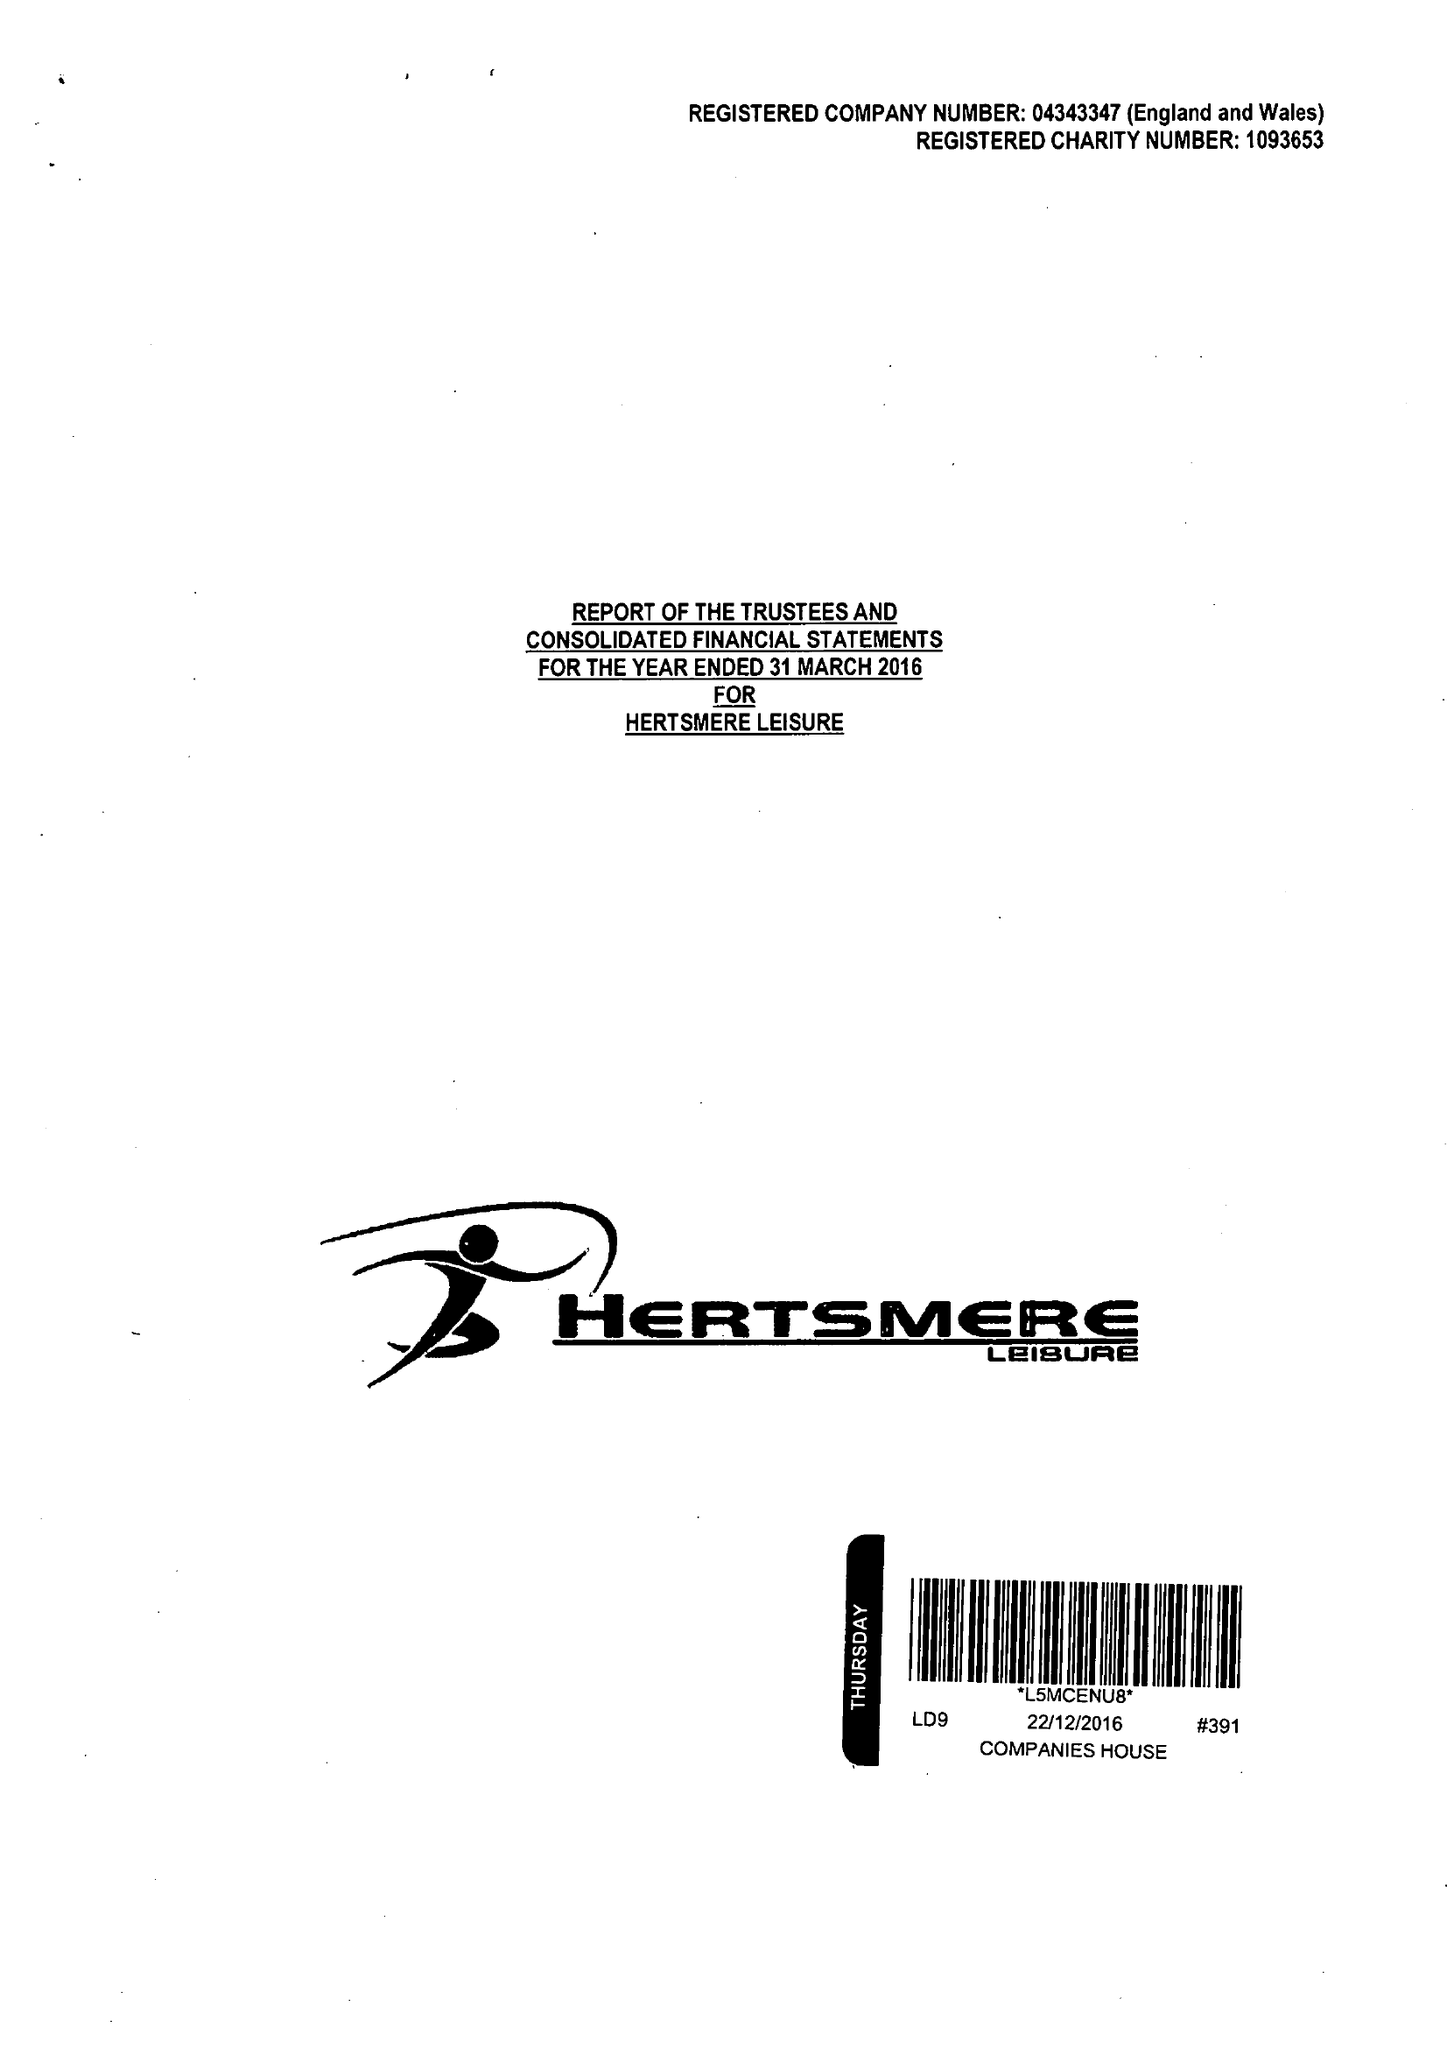What is the value for the address__postcode?
Answer the question using a single word or phrase. WD6 1JY 